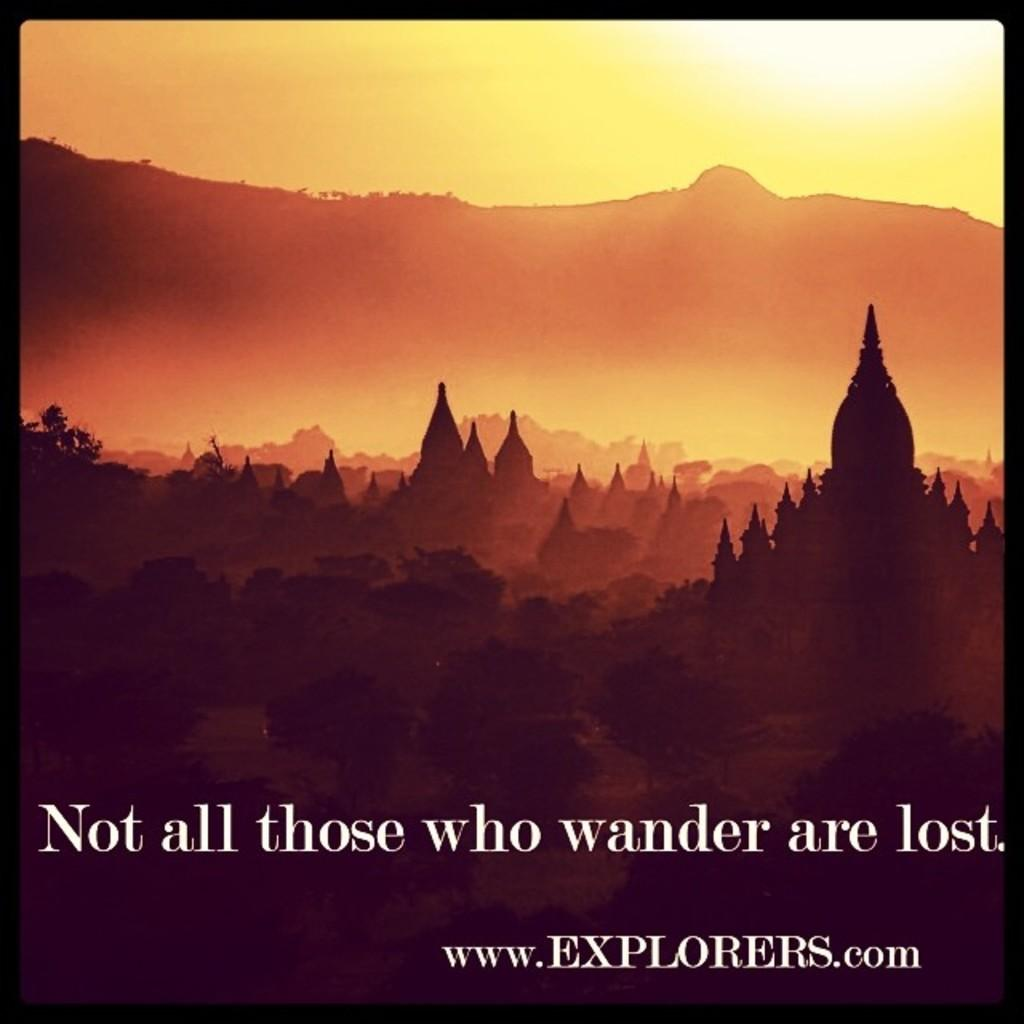<image>
Relay a brief, clear account of the picture shown. An explorers.com scenic poster stating "not all those who wander are lost." 